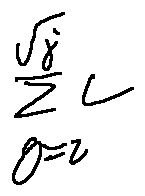Convert formula to latex. <formula><loc_0><loc_0><loc_500><loc_500>\sum \lim i t s _ { g = z } ^ { \sqrt { j } } L</formula> 